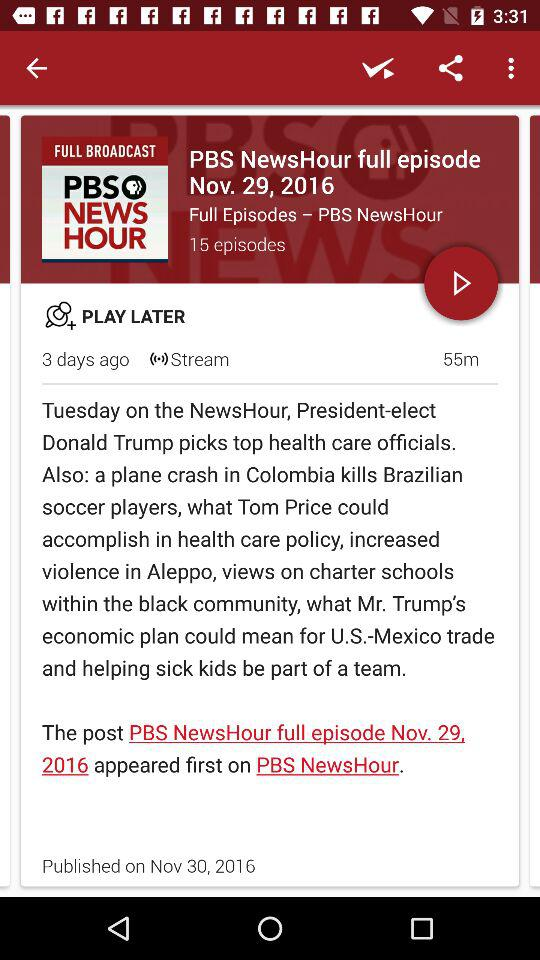How long is the episode? The episode is 55 minutes long. 